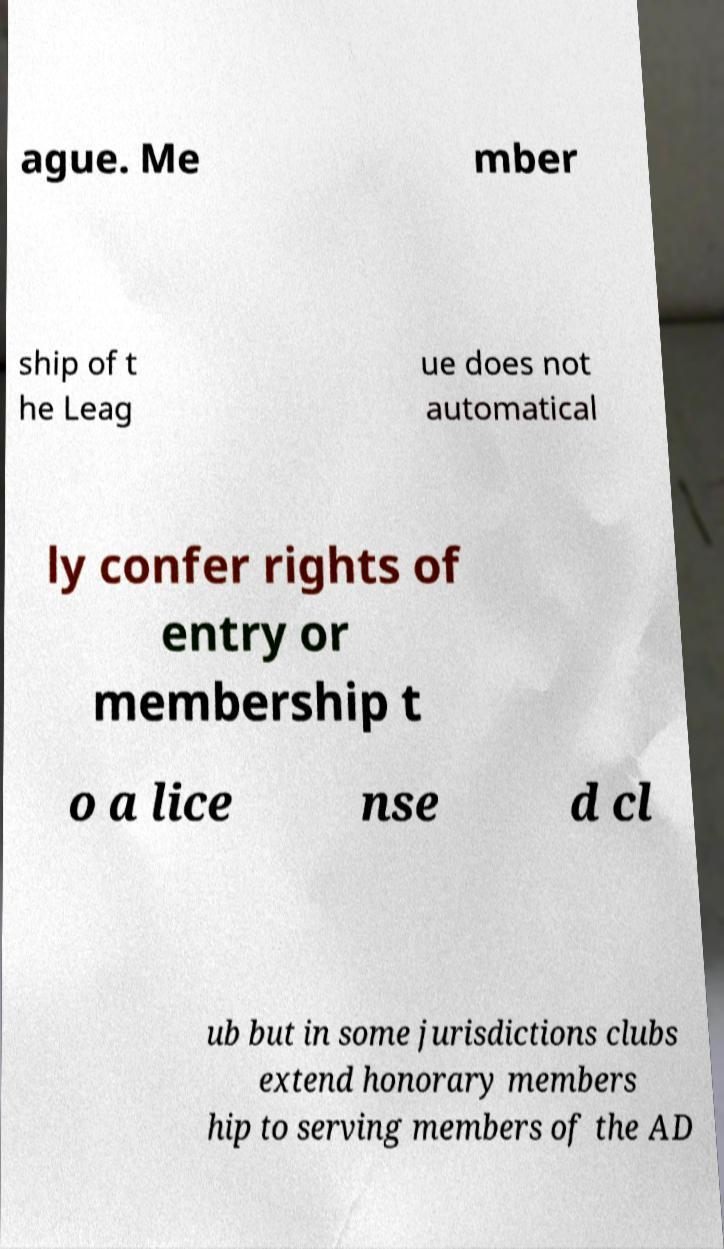What messages or text are displayed in this image? I need them in a readable, typed format. ague. Me mber ship of t he Leag ue does not automatical ly confer rights of entry or membership t o a lice nse d cl ub but in some jurisdictions clubs extend honorary members hip to serving members of the AD 